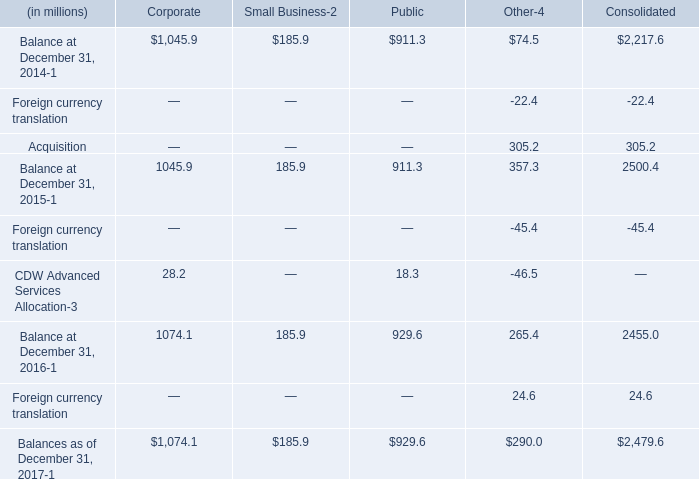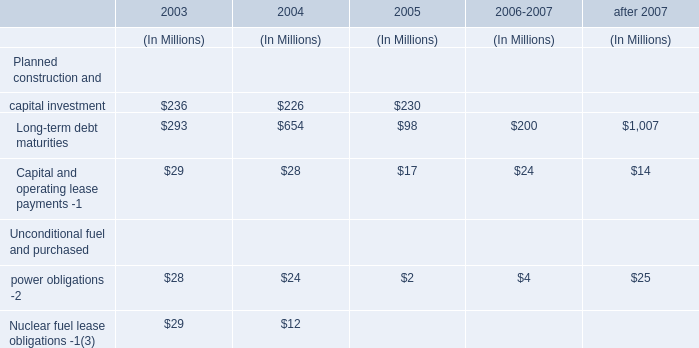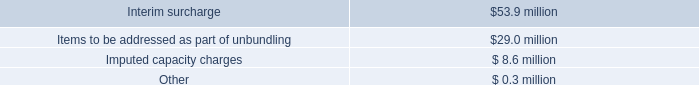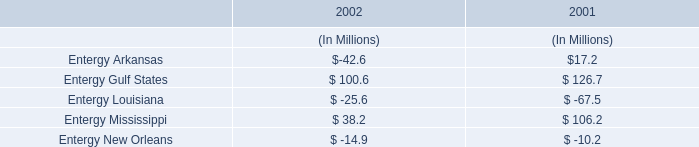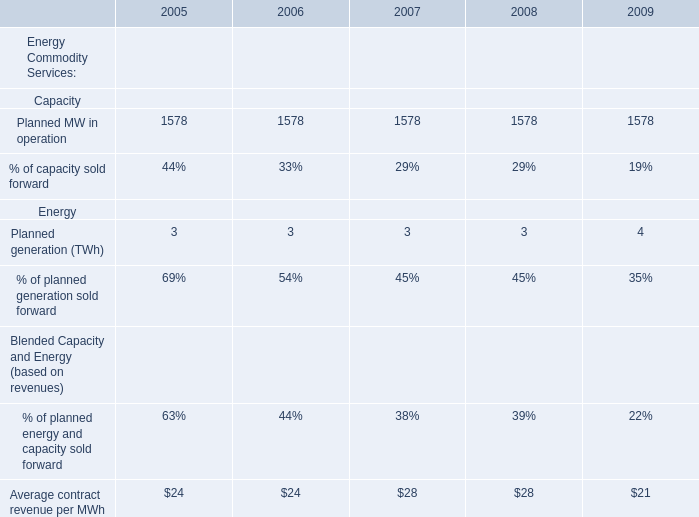What's the average of Planned MW in operation in 2005, 2006, and 2007? 
Computations: (((1578 + 1578) + 1578) / 3)
Answer: 1578.0. 